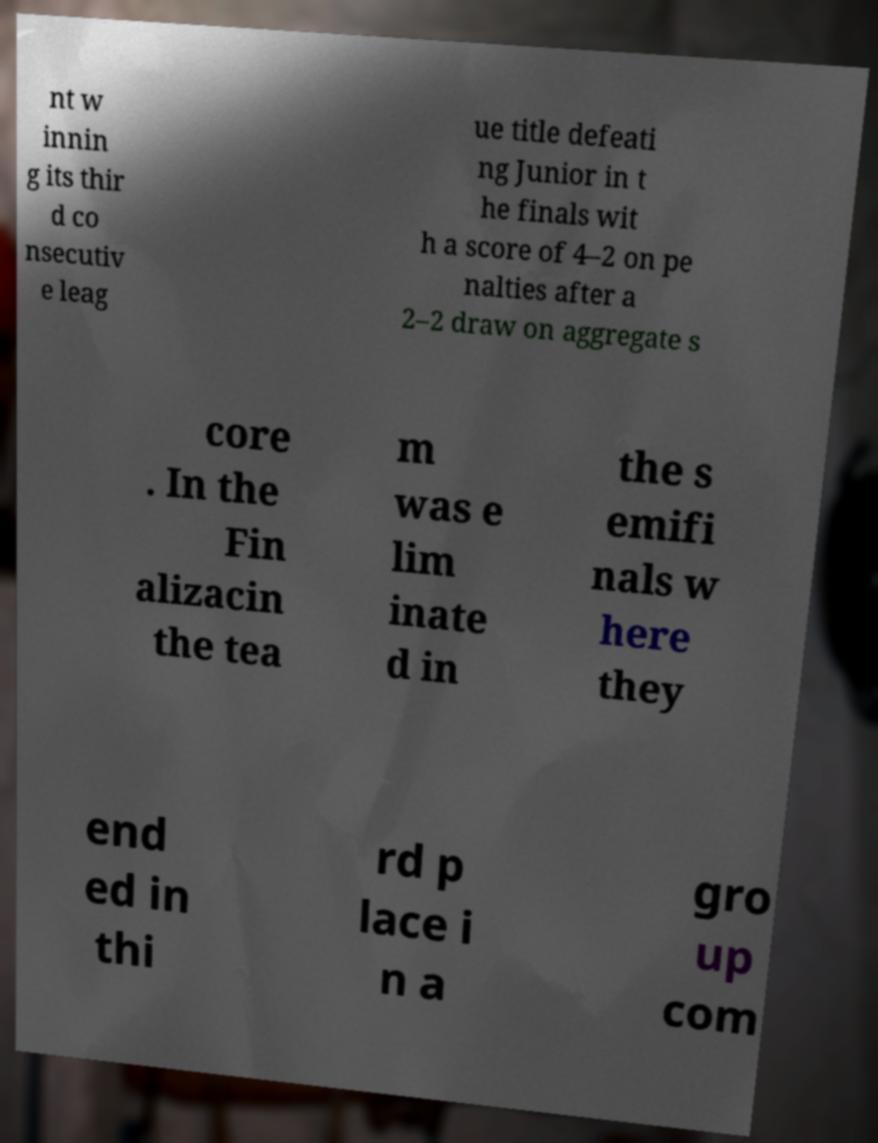What messages or text are displayed in this image? I need them in a readable, typed format. nt w innin g its thir d co nsecutiv e leag ue title defeati ng Junior in t he finals wit h a score of 4–2 on pe nalties after a 2–2 draw on aggregate s core . In the Fin alizacin the tea m was e lim inate d in the s emifi nals w here they end ed in thi rd p lace i n a gro up com 